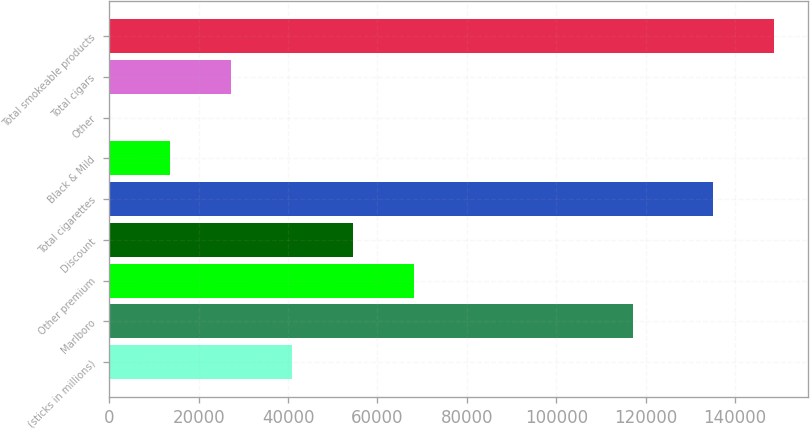Convert chart. <chart><loc_0><loc_0><loc_500><loc_500><bar_chart><fcel>(sticks in millions)<fcel>Marlboro<fcel>Other premium<fcel>Discount<fcel>Total cigarettes<fcel>Black & Mild<fcel>Other<fcel>Total cigars<fcel>Total smokeable products<nl><fcel>40929.2<fcel>117201<fcel>68202<fcel>54565.6<fcel>135138<fcel>13656.4<fcel>20<fcel>27292.8<fcel>148774<nl></chart> 